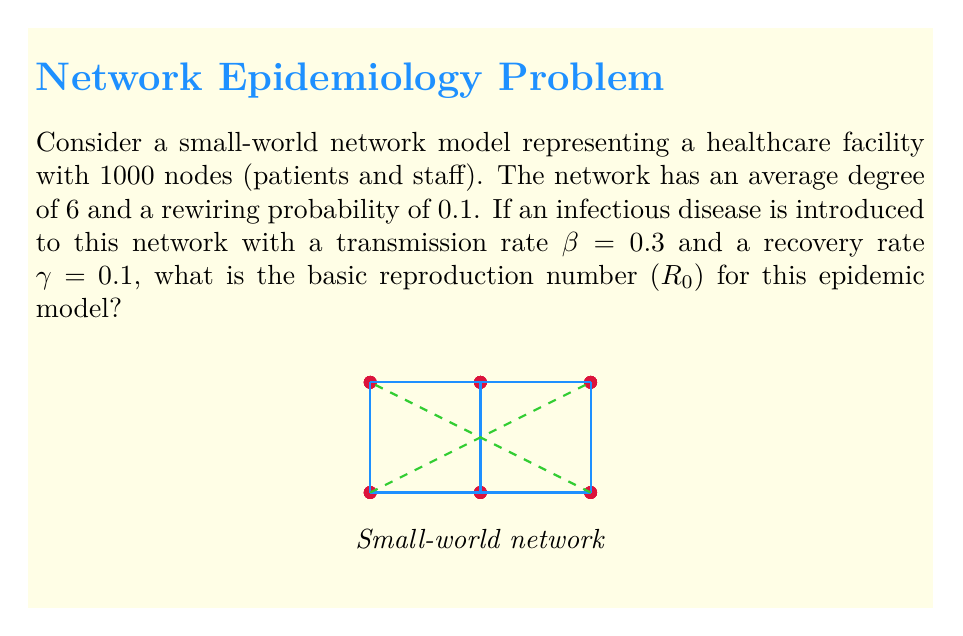Teach me how to tackle this problem. To solve this problem, we need to understand the components of the basic reproduction number (R₀) in the context of a network-based epidemic model:

1. The basic reproduction number is defined as the average number of secondary infections caused by a single infected individual in a completely susceptible population.

2. In a network model, R₀ is influenced by the network structure and the disease parameters. For a small-world network, we can approximate R₀ using the mean-field theory:

   $$R_0 \approx \frac{\beta}{\gamma} \cdot \langle k \rangle$$

   where $\beta$ is the transmission rate, $\gamma$ is the recovery rate, and $\langle k \rangle$ is the average degree of the network.

3. Given information:
   - Transmission rate: $\beta = 0.3$
   - Recovery rate: $\gamma = 0.1$
   - Average degree: $\langle k \rangle = 6$

4. Plugging these values into the formula:

   $$R_0 \approx \frac{0.3}{0.1} \cdot 6$$

5. Simplifying:

   $$R_0 \approx 3 \cdot 6 = 18$$

Therefore, the basic reproduction number (R₀) for this epidemic model on the given small-world network is approximately 18.
Answer: 18 